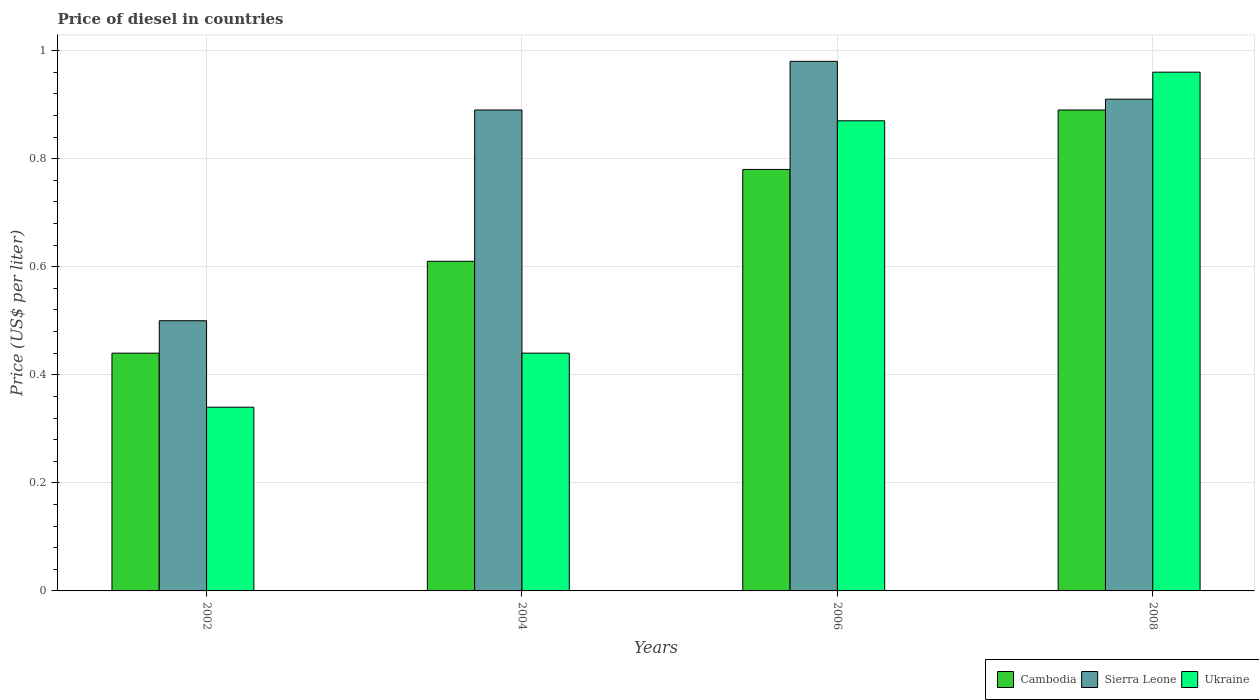How many different coloured bars are there?
Keep it short and to the point. 3. Are the number of bars per tick equal to the number of legend labels?
Offer a very short reply. Yes. How many bars are there on the 4th tick from the left?
Give a very brief answer. 3. How many bars are there on the 4th tick from the right?
Your answer should be very brief. 3. In how many cases, is the number of bars for a given year not equal to the number of legend labels?
Offer a terse response. 0. What is the price of diesel in Ukraine in 2002?
Make the answer very short. 0.34. Across all years, what is the maximum price of diesel in Cambodia?
Your answer should be compact. 0.89. Across all years, what is the minimum price of diesel in Sierra Leone?
Make the answer very short. 0.5. What is the total price of diesel in Sierra Leone in the graph?
Your answer should be very brief. 3.28. What is the difference between the price of diesel in Ukraine in 2002 and that in 2008?
Your answer should be compact. -0.62. What is the difference between the price of diesel in Ukraine in 2006 and the price of diesel in Sierra Leone in 2002?
Ensure brevity in your answer.  0.37. What is the average price of diesel in Ukraine per year?
Offer a very short reply. 0.65. In the year 2002, what is the difference between the price of diesel in Cambodia and price of diesel in Sierra Leone?
Your answer should be very brief. -0.06. What is the ratio of the price of diesel in Cambodia in 2002 to that in 2006?
Provide a succinct answer. 0.56. What is the difference between the highest and the second highest price of diesel in Sierra Leone?
Ensure brevity in your answer.  0.07. What is the difference between the highest and the lowest price of diesel in Ukraine?
Your answer should be compact. 0.62. In how many years, is the price of diesel in Cambodia greater than the average price of diesel in Cambodia taken over all years?
Provide a short and direct response. 2. Is the sum of the price of diesel in Sierra Leone in 2004 and 2006 greater than the maximum price of diesel in Ukraine across all years?
Offer a terse response. Yes. What does the 3rd bar from the left in 2006 represents?
Your answer should be very brief. Ukraine. What does the 2nd bar from the right in 2004 represents?
Keep it short and to the point. Sierra Leone. How many bars are there?
Provide a short and direct response. 12. Are all the bars in the graph horizontal?
Keep it short and to the point. No. Does the graph contain grids?
Your response must be concise. Yes. How many legend labels are there?
Give a very brief answer. 3. What is the title of the graph?
Your response must be concise. Price of diesel in countries. What is the label or title of the X-axis?
Ensure brevity in your answer.  Years. What is the label or title of the Y-axis?
Your answer should be very brief. Price (US$ per liter). What is the Price (US$ per liter) of Cambodia in 2002?
Provide a succinct answer. 0.44. What is the Price (US$ per liter) in Sierra Leone in 2002?
Your response must be concise. 0.5. What is the Price (US$ per liter) in Ukraine in 2002?
Make the answer very short. 0.34. What is the Price (US$ per liter) of Cambodia in 2004?
Provide a short and direct response. 0.61. What is the Price (US$ per liter) of Sierra Leone in 2004?
Make the answer very short. 0.89. What is the Price (US$ per liter) in Ukraine in 2004?
Keep it short and to the point. 0.44. What is the Price (US$ per liter) of Cambodia in 2006?
Make the answer very short. 0.78. What is the Price (US$ per liter) in Sierra Leone in 2006?
Provide a succinct answer. 0.98. What is the Price (US$ per liter) in Ukraine in 2006?
Your answer should be very brief. 0.87. What is the Price (US$ per liter) of Cambodia in 2008?
Give a very brief answer. 0.89. What is the Price (US$ per liter) of Sierra Leone in 2008?
Give a very brief answer. 0.91. Across all years, what is the maximum Price (US$ per liter) of Cambodia?
Your answer should be compact. 0.89. Across all years, what is the minimum Price (US$ per liter) of Cambodia?
Keep it short and to the point. 0.44. Across all years, what is the minimum Price (US$ per liter) of Ukraine?
Provide a succinct answer. 0.34. What is the total Price (US$ per liter) in Cambodia in the graph?
Your answer should be very brief. 2.72. What is the total Price (US$ per liter) in Sierra Leone in the graph?
Make the answer very short. 3.28. What is the total Price (US$ per liter) of Ukraine in the graph?
Keep it short and to the point. 2.61. What is the difference between the Price (US$ per liter) in Cambodia in 2002 and that in 2004?
Make the answer very short. -0.17. What is the difference between the Price (US$ per liter) of Sierra Leone in 2002 and that in 2004?
Offer a very short reply. -0.39. What is the difference between the Price (US$ per liter) in Cambodia in 2002 and that in 2006?
Provide a short and direct response. -0.34. What is the difference between the Price (US$ per liter) in Sierra Leone in 2002 and that in 2006?
Offer a very short reply. -0.48. What is the difference between the Price (US$ per liter) in Ukraine in 2002 and that in 2006?
Ensure brevity in your answer.  -0.53. What is the difference between the Price (US$ per liter) of Cambodia in 2002 and that in 2008?
Keep it short and to the point. -0.45. What is the difference between the Price (US$ per liter) of Sierra Leone in 2002 and that in 2008?
Your answer should be compact. -0.41. What is the difference between the Price (US$ per liter) of Ukraine in 2002 and that in 2008?
Your response must be concise. -0.62. What is the difference between the Price (US$ per liter) of Cambodia in 2004 and that in 2006?
Your answer should be very brief. -0.17. What is the difference between the Price (US$ per liter) of Sierra Leone in 2004 and that in 2006?
Your answer should be very brief. -0.09. What is the difference between the Price (US$ per liter) of Ukraine in 2004 and that in 2006?
Provide a succinct answer. -0.43. What is the difference between the Price (US$ per liter) of Cambodia in 2004 and that in 2008?
Your answer should be very brief. -0.28. What is the difference between the Price (US$ per liter) in Sierra Leone in 2004 and that in 2008?
Give a very brief answer. -0.02. What is the difference between the Price (US$ per liter) in Ukraine in 2004 and that in 2008?
Your answer should be compact. -0.52. What is the difference between the Price (US$ per liter) of Cambodia in 2006 and that in 2008?
Provide a short and direct response. -0.11. What is the difference between the Price (US$ per liter) of Sierra Leone in 2006 and that in 2008?
Provide a succinct answer. 0.07. What is the difference between the Price (US$ per liter) of Ukraine in 2006 and that in 2008?
Your response must be concise. -0.09. What is the difference between the Price (US$ per liter) of Cambodia in 2002 and the Price (US$ per liter) of Sierra Leone in 2004?
Provide a short and direct response. -0.45. What is the difference between the Price (US$ per liter) of Cambodia in 2002 and the Price (US$ per liter) of Ukraine in 2004?
Your answer should be very brief. 0. What is the difference between the Price (US$ per liter) of Sierra Leone in 2002 and the Price (US$ per liter) of Ukraine in 2004?
Your answer should be compact. 0.06. What is the difference between the Price (US$ per liter) in Cambodia in 2002 and the Price (US$ per liter) in Sierra Leone in 2006?
Offer a terse response. -0.54. What is the difference between the Price (US$ per liter) of Cambodia in 2002 and the Price (US$ per liter) of Ukraine in 2006?
Provide a short and direct response. -0.43. What is the difference between the Price (US$ per liter) of Sierra Leone in 2002 and the Price (US$ per liter) of Ukraine in 2006?
Offer a very short reply. -0.37. What is the difference between the Price (US$ per liter) in Cambodia in 2002 and the Price (US$ per liter) in Sierra Leone in 2008?
Give a very brief answer. -0.47. What is the difference between the Price (US$ per liter) of Cambodia in 2002 and the Price (US$ per liter) of Ukraine in 2008?
Give a very brief answer. -0.52. What is the difference between the Price (US$ per liter) in Sierra Leone in 2002 and the Price (US$ per liter) in Ukraine in 2008?
Provide a short and direct response. -0.46. What is the difference between the Price (US$ per liter) of Cambodia in 2004 and the Price (US$ per liter) of Sierra Leone in 2006?
Your response must be concise. -0.37. What is the difference between the Price (US$ per liter) in Cambodia in 2004 and the Price (US$ per liter) in Ukraine in 2006?
Offer a terse response. -0.26. What is the difference between the Price (US$ per liter) of Sierra Leone in 2004 and the Price (US$ per liter) of Ukraine in 2006?
Your answer should be very brief. 0.02. What is the difference between the Price (US$ per liter) of Cambodia in 2004 and the Price (US$ per liter) of Ukraine in 2008?
Provide a short and direct response. -0.35. What is the difference between the Price (US$ per liter) of Sierra Leone in 2004 and the Price (US$ per liter) of Ukraine in 2008?
Provide a short and direct response. -0.07. What is the difference between the Price (US$ per liter) in Cambodia in 2006 and the Price (US$ per liter) in Sierra Leone in 2008?
Your answer should be compact. -0.13. What is the difference between the Price (US$ per liter) of Cambodia in 2006 and the Price (US$ per liter) of Ukraine in 2008?
Ensure brevity in your answer.  -0.18. What is the average Price (US$ per liter) in Cambodia per year?
Ensure brevity in your answer.  0.68. What is the average Price (US$ per liter) in Sierra Leone per year?
Offer a terse response. 0.82. What is the average Price (US$ per liter) of Ukraine per year?
Your response must be concise. 0.65. In the year 2002, what is the difference between the Price (US$ per liter) of Cambodia and Price (US$ per liter) of Sierra Leone?
Ensure brevity in your answer.  -0.06. In the year 2002, what is the difference between the Price (US$ per liter) in Cambodia and Price (US$ per liter) in Ukraine?
Your response must be concise. 0.1. In the year 2002, what is the difference between the Price (US$ per liter) in Sierra Leone and Price (US$ per liter) in Ukraine?
Your answer should be compact. 0.16. In the year 2004, what is the difference between the Price (US$ per liter) of Cambodia and Price (US$ per liter) of Sierra Leone?
Keep it short and to the point. -0.28. In the year 2004, what is the difference between the Price (US$ per liter) of Cambodia and Price (US$ per liter) of Ukraine?
Make the answer very short. 0.17. In the year 2004, what is the difference between the Price (US$ per liter) in Sierra Leone and Price (US$ per liter) in Ukraine?
Your answer should be very brief. 0.45. In the year 2006, what is the difference between the Price (US$ per liter) of Cambodia and Price (US$ per liter) of Ukraine?
Offer a terse response. -0.09. In the year 2006, what is the difference between the Price (US$ per liter) of Sierra Leone and Price (US$ per liter) of Ukraine?
Your response must be concise. 0.11. In the year 2008, what is the difference between the Price (US$ per liter) of Cambodia and Price (US$ per liter) of Sierra Leone?
Your answer should be very brief. -0.02. In the year 2008, what is the difference between the Price (US$ per liter) of Cambodia and Price (US$ per liter) of Ukraine?
Your answer should be very brief. -0.07. What is the ratio of the Price (US$ per liter) of Cambodia in 2002 to that in 2004?
Ensure brevity in your answer.  0.72. What is the ratio of the Price (US$ per liter) in Sierra Leone in 2002 to that in 2004?
Offer a very short reply. 0.56. What is the ratio of the Price (US$ per liter) in Ukraine in 2002 to that in 2004?
Ensure brevity in your answer.  0.77. What is the ratio of the Price (US$ per liter) in Cambodia in 2002 to that in 2006?
Offer a terse response. 0.56. What is the ratio of the Price (US$ per liter) of Sierra Leone in 2002 to that in 2006?
Give a very brief answer. 0.51. What is the ratio of the Price (US$ per liter) in Ukraine in 2002 to that in 2006?
Ensure brevity in your answer.  0.39. What is the ratio of the Price (US$ per liter) of Cambodia in 2002 to that in 2008?
Make the answer very short. 0.49. What is the ratio of the Price (US$ per liter) of Sierra Leone in 2002 to that in 2008?
Ensure brevity in your answer.  0.55. What is the ratio of the Price (US$ per liter) in Ukraine in 2002 to that in 2008?
Give a very brief answer. 0.35. What is the ratio of the Price (US$ per liter) in Cambodia in 2004 to that in 2006?
Your answer should be compact. 0.78. What is the ratio of the Price (US$ per liter) in Sierra Leone in 2004 to that in 2006?
Offer a terse response. 0.91. What is the ratio of the Price (US$ per liter) of Ukraine in 2004 to that in 2006?
Provide a succinct answer. 0.51. What is the ratio of the Price (US$ per liter) of Cambodia in 2004 to that in 2008?
Keep it short and to the point. 0.69. What is the ratio of the Price (US$ per liter) in Ukraine in 2004 to that in 2008?
Your response must be concise. 0.46. What is the ratio of the Price (US$ per liter) of Cambodia in 2006 to that in 2008?
Offer a terse response. 0.88. What is the ratio of the Price (US$ per liter) of Sierra Leone in 2006 to that in 2008?
Offer a terse response. 1.08. What is the ratio of the Price (US$ per liter) of Ukraine in 2006 to that in 2008?
Offer a very short reply. 0.91. What is the difference between the highest and the second highest Price (US$ per liter) in Cambodia?
Ensure brevity in your answer.  0.11. What is the difference between the highest and the second highest Price (US$ per liter) of Sierra Leone?
Provide a short and direct response. 0.07. What is the difference between the highest and the second highest Price (US$ per liter) of Ukraine?
Make the answer very short. 0.09. What is the difference between the highest and the lowest Price (US$ per liter) in Cambodia?
Your response must be concise. 0.45. What is the difference between the highest and the lowest Price (US$ per liter) in Sierra Leone?
Provide a short and direct response. 0.48. What is the difference between the highest and the lowest Price (US$ per liter) in Ukraine?
Keep it short and to the point. 0.62. 